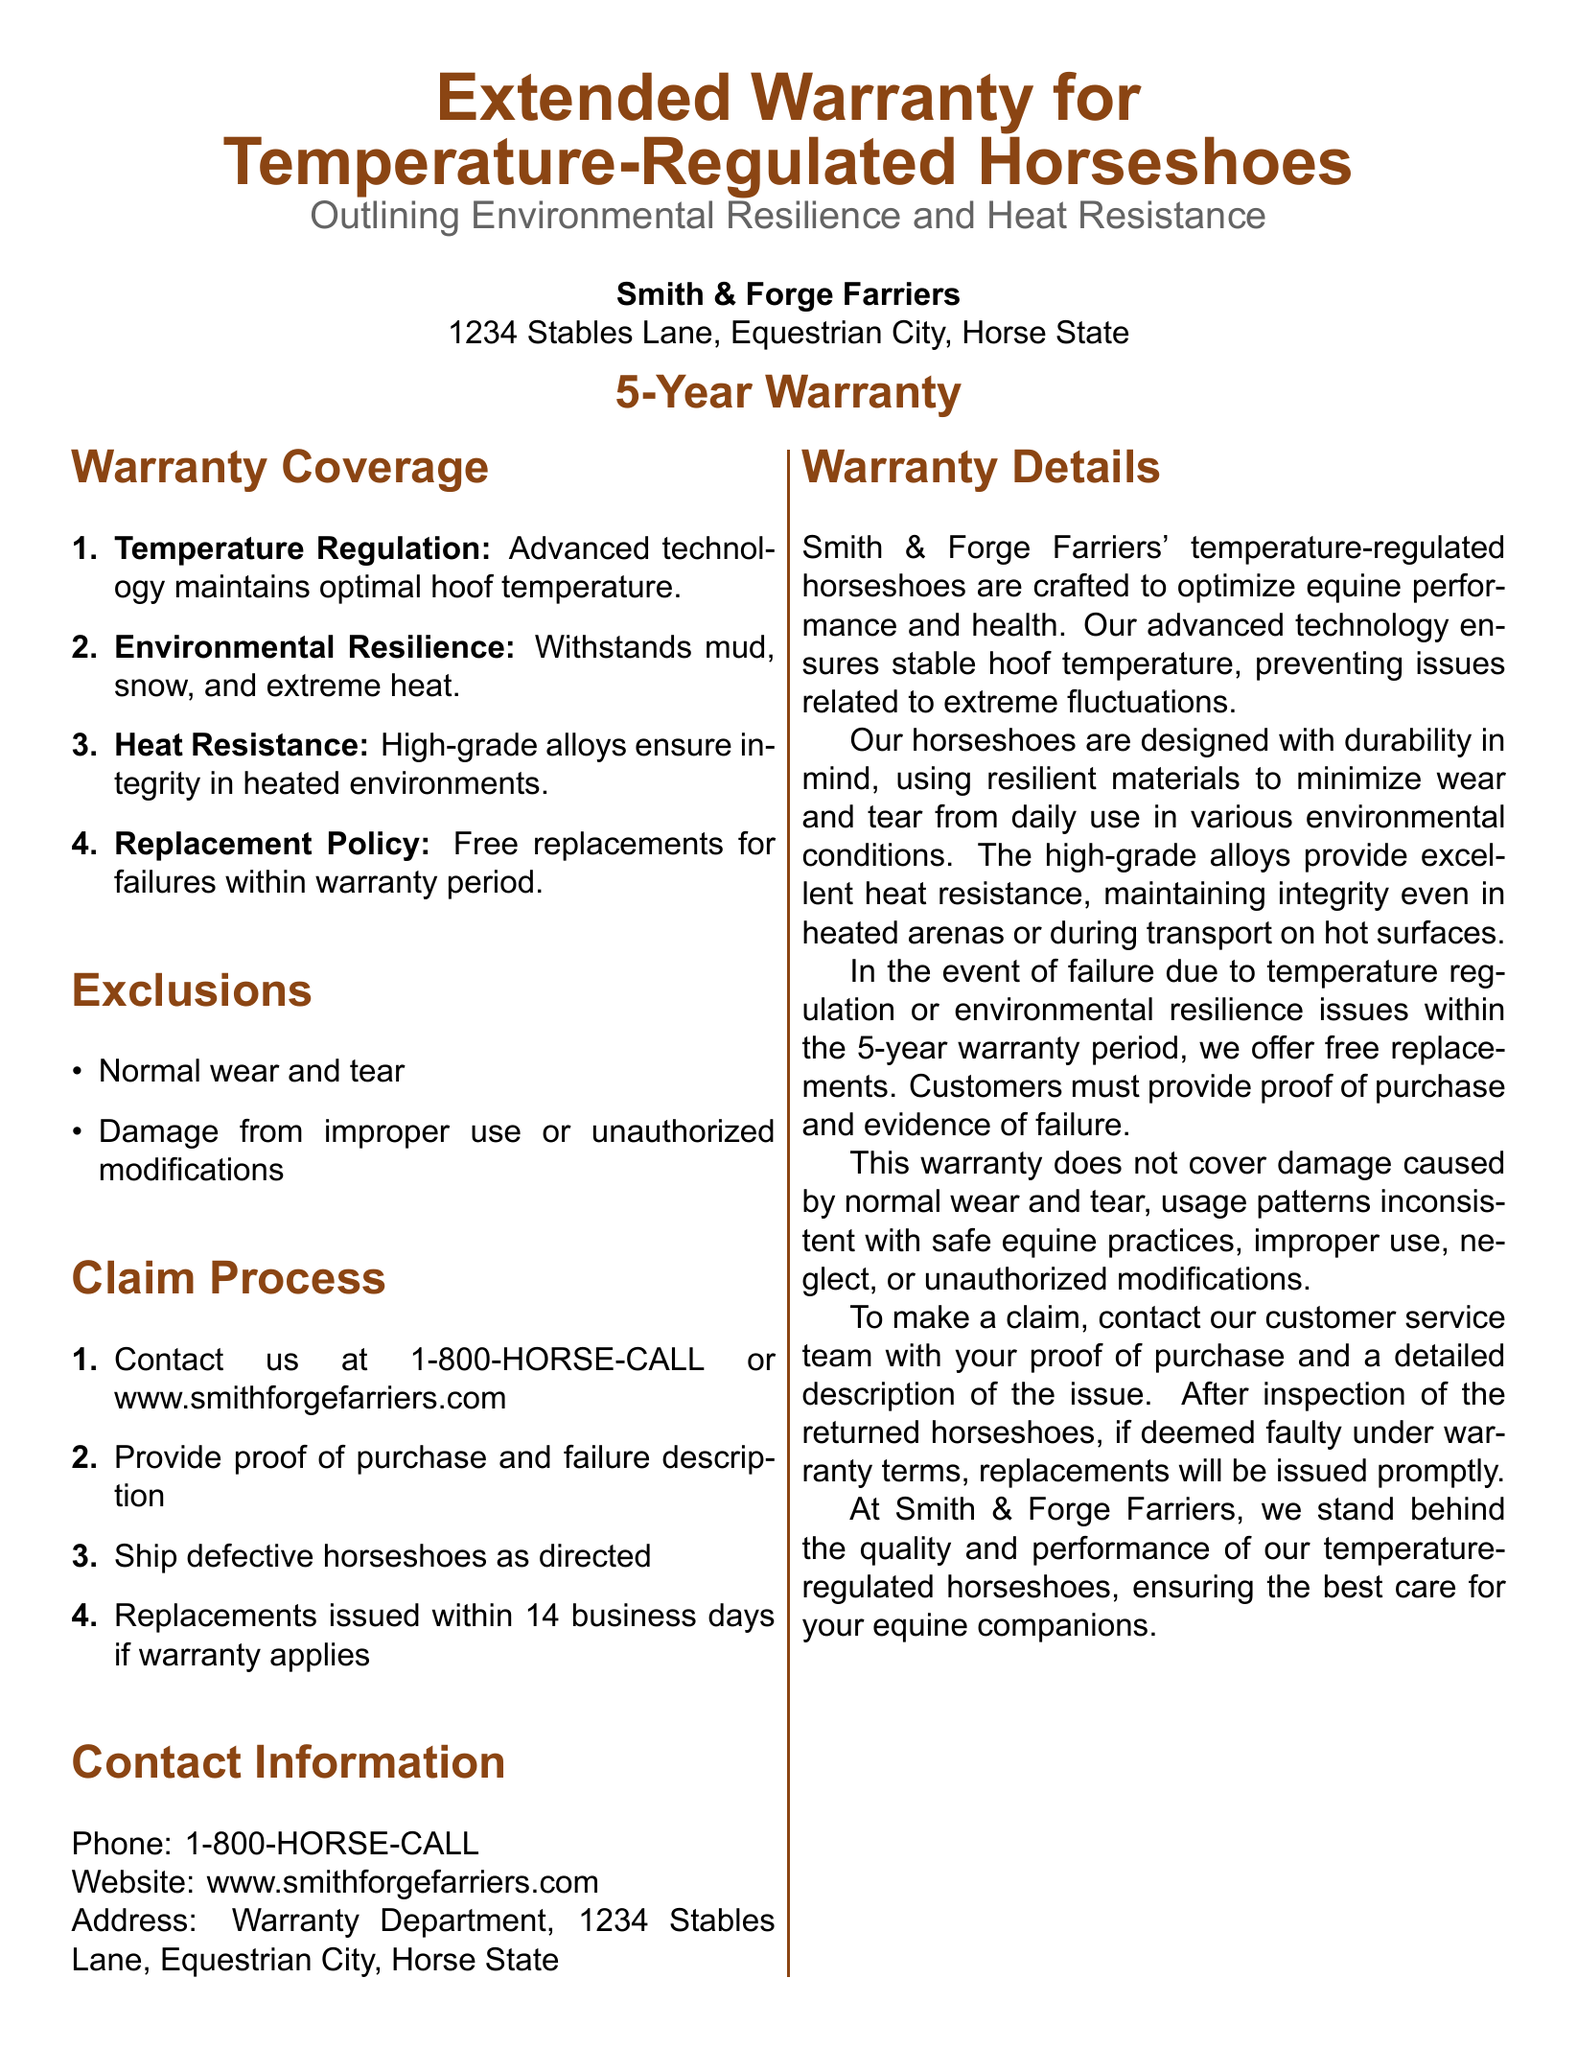What is the duration of the warranty? The warranty is valid for a specific period mentioned in the document, which is 5 years.
Answer: 5 years What kind of technology do the horseshoes use? The document states that the horseshoes utilize advanced technology for temperature regulation.
Answer: Advanced technology What materials ensure the horseshoes' heat resistance? The document highlights that high-grade alloys are used for heat resistance.
Answer: High-grade alloys What should you provide to make a warranty claim? The process for making a claim requires proof of purchase and a description of the failure issue.
Answer: Proof of purchase and failure description What types of damage are excluded from the warranty? The document explicitly mentions that normal wear and damage from improper use are excluded from the warranty coverage.
Answer: Normal wear and tear; Damage from improper use What is the contact number for claims? The document provides a specific phone number for customers to contact regarding warranty claims.
Answer: 1-800-HORSE-CALL How long will it take to receive a replacement if the warranty is applicable? The document specifies the timeframe for issuing replacements after an inspection of the returned horseshoes as 14 business days.
Answer: 14 business days What environmental conditions can the horseshoes withstand? The document states that the horseshoes can withstand mud, snow, and extreme heat, showcasing their environmental resilience.
Answer: Mud, snow, and extreme heat What happens if the horseshoes fail within the warranty period? The warranty includes a policy for free replacements if horseshoes fail under the warranty terms.
Answer: Free replacements 